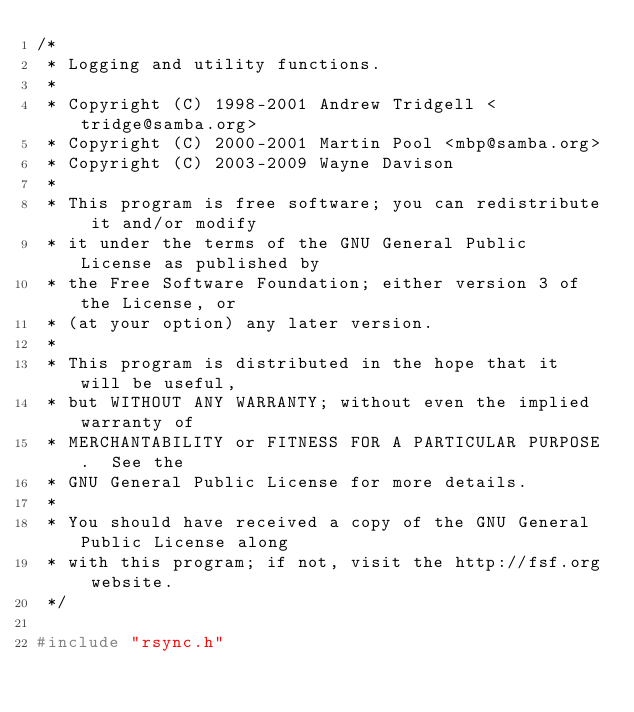Convert code to text. <code><loc_0><loc_0><loc_500><loc_500><_C_>/*
 * Logging and utility functions.
 *
 * Copyright (C) 1998-2001 Andrew Tridgell <tridge@samba.org>
 * Copyright (C) 2000-2001 Martin Pool <mbp@samba.org>
 * Copyright (C) 2003-2009 Wayne Davison
 *
 * This program is free software; you can redistribute it and/or modify
 * it under the terms of the GNU General Public License as published by
 * the Free Software Foundation; either version 3 of the License, or
 * (at your option) any later version.
 *
 * This program is distributed in the hope that it will be useful,
 * but WITHOUT ANY WARRANTY; without even the implied warranty of
 * MERCHANTABILITY or FITNESS FOR A PARTICULAR PURPOSE.  See the
 * GNU General Public License for more details.
 *
 * You should have received a copy of the GNU General Public License along
 * with this program; if not, visit the http://fsf.org website.
 */

#include "rsync.h"</code> 